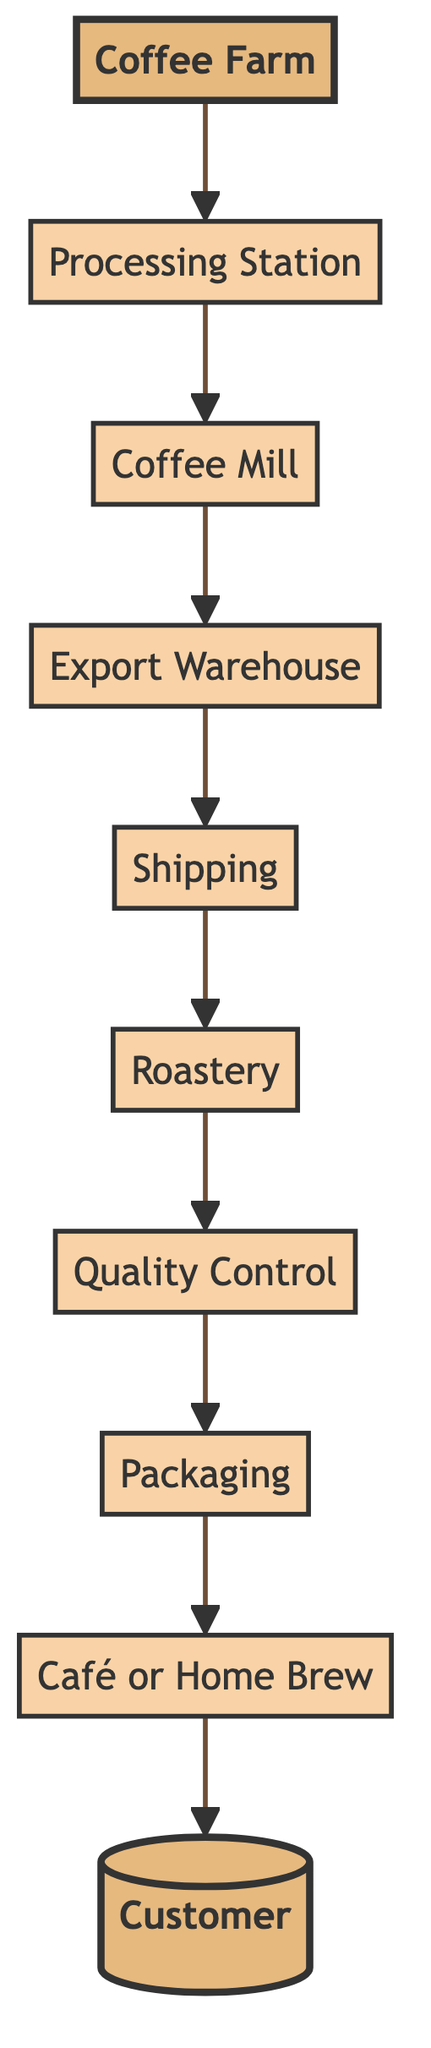What is the first stage in the coffee journey? The diagram indicates that the first stage in the coffee journey is the Coffee Farm, where coffee cherries are grown and harvested.
Answer: Coffee Farm Which node comes after Quality Control in the diagram? After Quality Control, the next stage in the flow chart is Packaging, where roasted beans are packaged for retail.
Answer: Packaging How many nodes are present in the diagram? By counting the different stages from Coffee Farm to Customer, there are a total of 10 nodes represented in the diagram.
Answer: 10 What is the last stage before the Customer receives the coffee? The last stage before the Customer receives the coffee is Café or Home Brew, where coffee is brewed and enjoyed.
Answer: Café or Home Brew What is the relationship between Processing Station and Coffee Mill? The Processing Station feeds into the Coffee Mill, which means the coffee cherries processed there are transformed into green coffee beans before moving on to the next step.
Answer: Processing Station → Coffee Mill Which stage involves tasting and approving the coffee batch? The stage involving tasting and approving the coffee batch is Quality Control, where professional cuppers evaluate the coffee before packaging.
Answer: Quality Control Name the stage where coffee is roasted to develop flavor profiles. The Roastery is the stage where green coffee beans are roasted to different levels, which helps develop the unique flavor profiles of the coffee.
Answer: Roastery In the flow from bottom to top, which node is directly linked to Shipping? The node directly linked to Shipping is Export Warehouse, signifying that the prepared coffee beans are transported from there.
Answer: Export Warehouse What are the main processes that occur after the Coffee Mill? After the Coffee Mill, the main processes are Export Warehouse followed by Shipping, indicating storage and then transport of the green coffee beans.
Answer: Export Warehouse, Shipping 